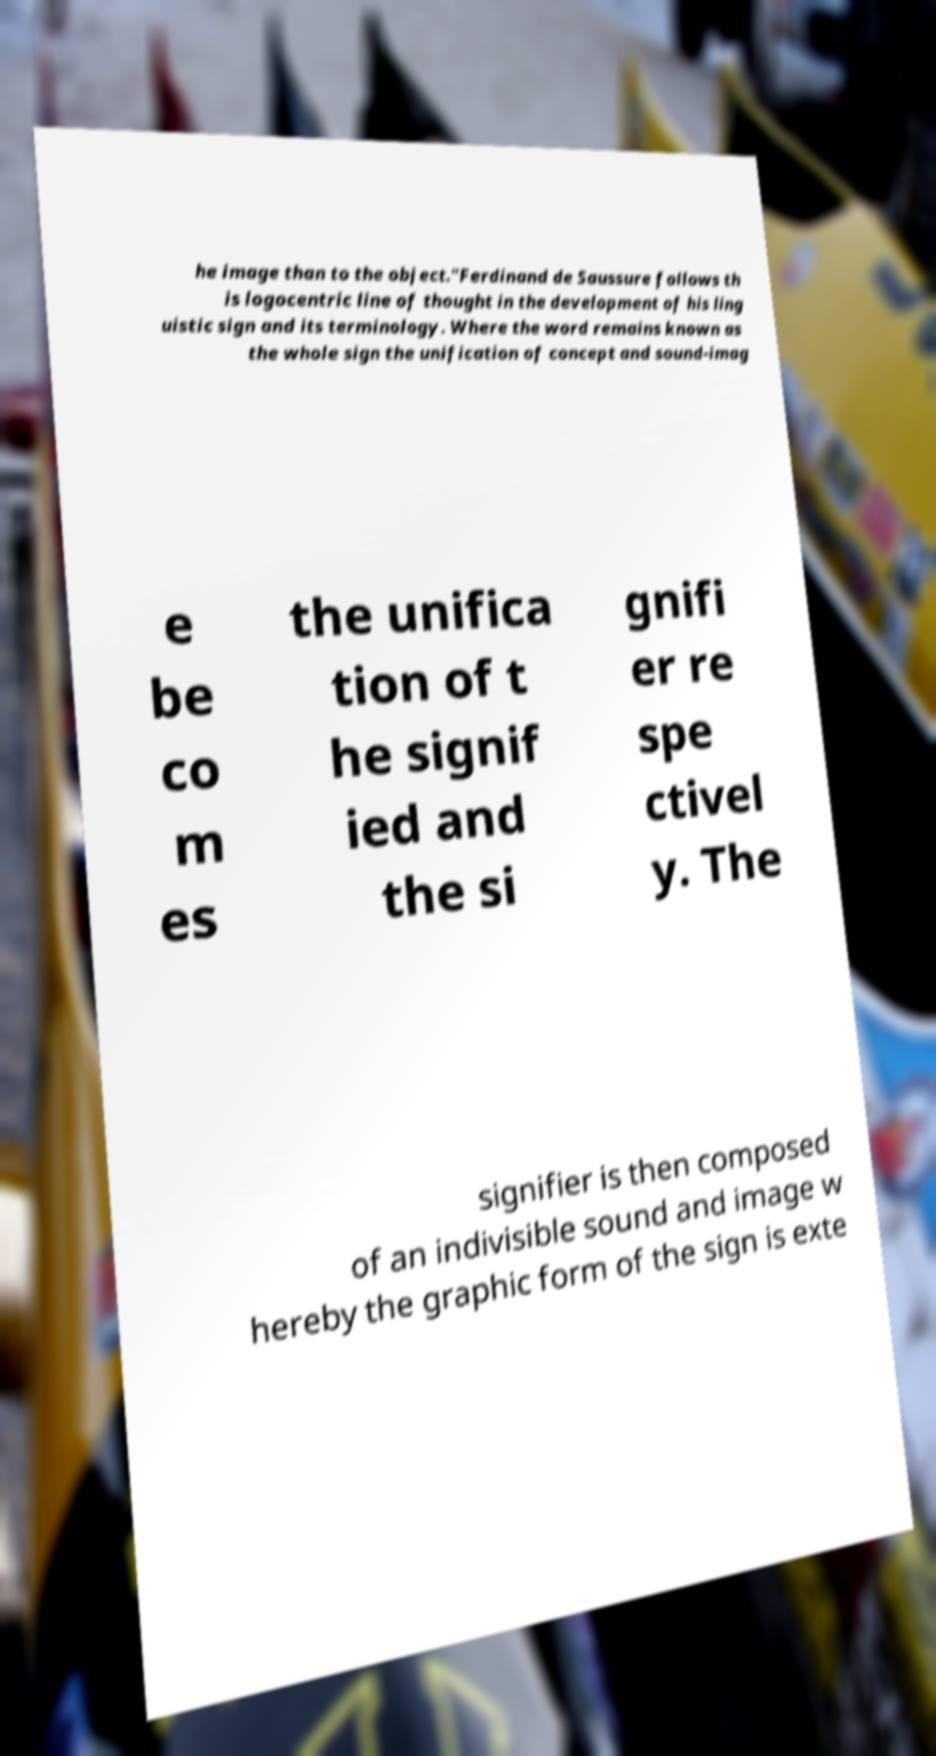For documentation purposes, I need the text within this image transcribed. Could you provide that? he image than to the object."Ferdinand de Saussure follows th is logocentric line of thought in the development of his ling uistic sign and its terminology. Where the word remains known as the whole sign the unification of concept and sound-imag e be co m es the unifica tion of t he signif ied and the si gnifi er re spe ctivel y. The signifier is then composed of an indivisible sound and image w hereby the graphic form of the sign is exte 